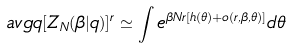Convert formula to latex. <formula><loc_0><loc_0><loc_500><loc_500>\ a v g q { [ Z _ { N } ( \beta | q ) ] ^ { r } } \simeq \int e ^ { \beta N r [ h ( \theta ) + o ( r , \beta , \theta ) ] } d \theta</formula> 